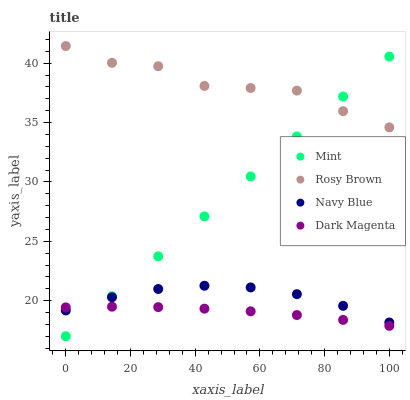Does Dark Magenta have the minimum area under the curve?
Answer yes or no. Yes. Does Rosy Brown have the maximum area under the curve?
Answer yes or no. Yes. Does Mint have the minimum area under the curve?
Answer yes or no. No. Does Mint have the maximum area under the curve?
Answer yes or no. No. Is Mint the smoothest?
Answer yes or no. Yes. Is Rosy Brown the roughest?
Answer yes or no. Yes. Is Rosy Brown the smoothest?
Answer yes or no. No. Is Mint the roughest?
Answer yes or no. No. Does Mint have the lowest value?
Answer yes or no. Yes. Does Rosy Brown have the lowest value?
Answer yes or no. No. Does Rosy Brown have the highest value?
Answer yes or no. Yes. Does Mint have the highest value?
Answer yes or no. No. Is Dark Magenta less than Rosy Brown?
Answer yes or no. Yes. Is Rosy Brown greater than Navy Blue?
Answer yes or no. Yes. Does Dark Magenta intersect Navy Blue?
Answer yes or no. Yes. Is Dark Magenta less than Navy Blue?
Answer yes or no. No. Is Dark Magenta greater than Navy Blue?
Answer yes or no. No. Does Dark Magenta intersect Rosy Brown?
Answer yes or no. No. 